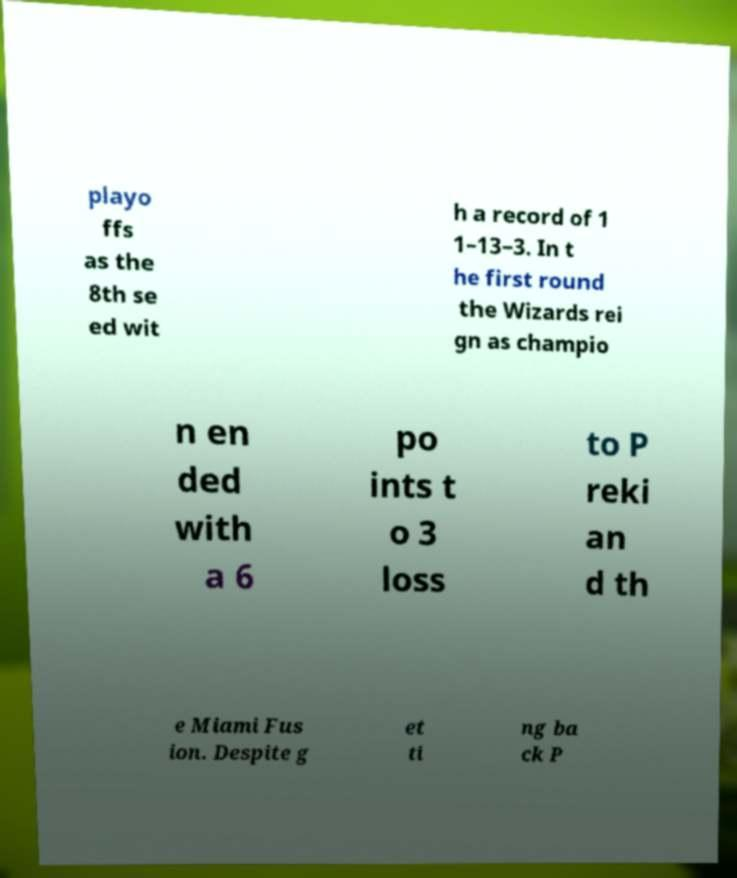Please identify and transcribe the text found in this image. playo ffs as the 8th se ed wit h a record of 1 1–13–3. In t he first round the Wizards rei gn as champio n en ded with a 6 po ints t o 3 loss to P reki an d th e Miami Fus ion. Despite g et ti ng ba ck P 